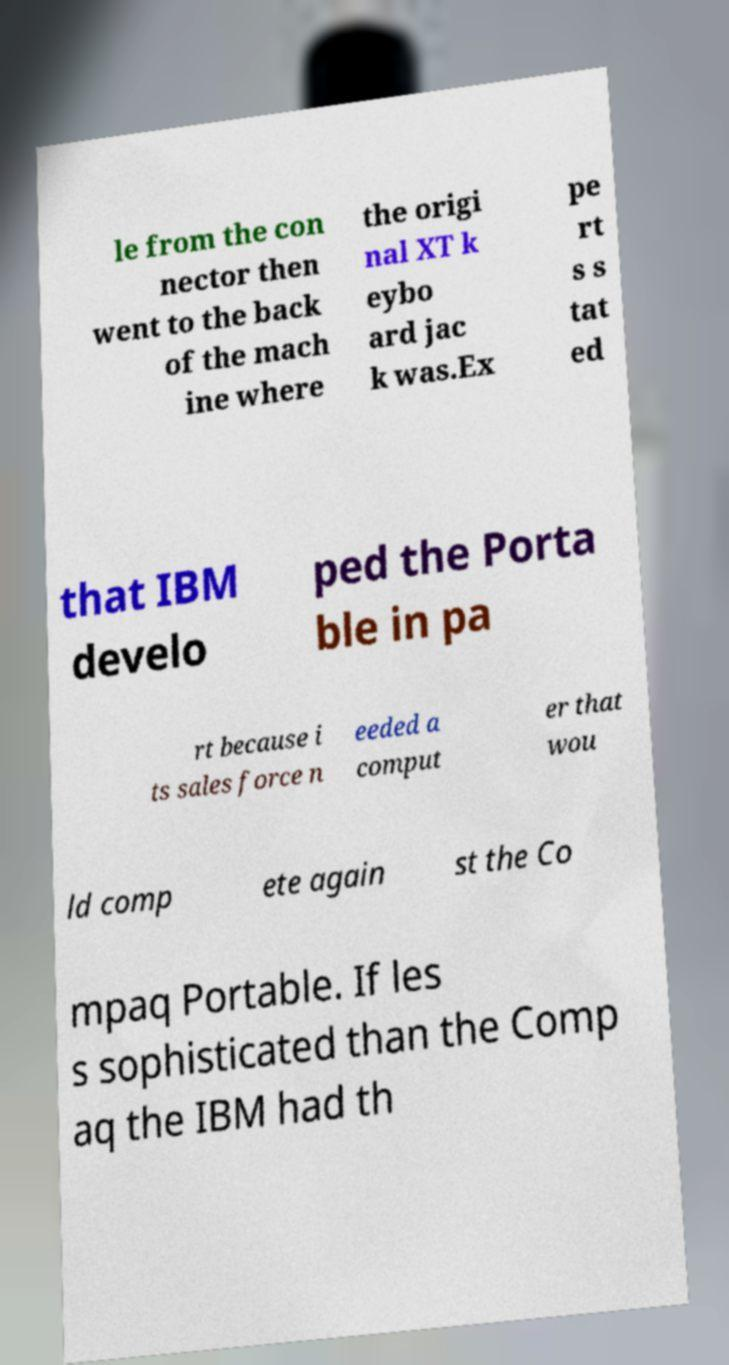For documentation purposes, I need the text within this image transcribed. Could you provide that? le from the con nector then went to the back of the mach ine where the origi nal XT k eybo ard jac k was.Ex pe rt s s tat ed that IBM develo ped the Porta ble in pa rt because i ts sales force n eeded a comput er that wou ld comp ete again st the Co mpaq Portable. If les s sophisticated than the Comp aq the IBM had th 